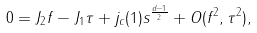<formula> <loc_0><loc_0><loc_500><loc_500>0 = J _ { 2 } f - J _ { 1 } \tau + j _ { c } ( 1 ) s ^ { \frac { d - 1 } { 2 } } + O ( f ^ { 2 } , \tau ^ { 2 } ) ,</formula> 